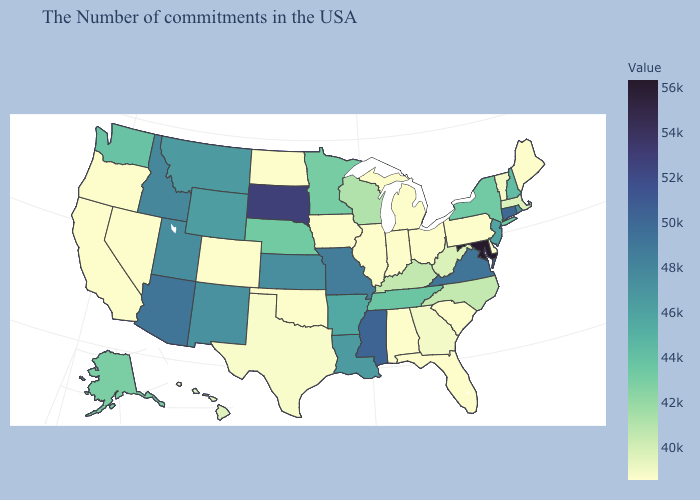Does the map have missing data?
Be succinct. No. Does Maryland have the highest value in the South?
Keep it brief. Yes. Does Alaska have a lower value than South Dakota?
Give a very brief answer. Yes. Among the states that border Colorado , which have the lowest value?
Short answer required. Oklahoma. Among the states that border Idaho , which have the lowest value?
Write a very short answer. Nevada, Oregon. 